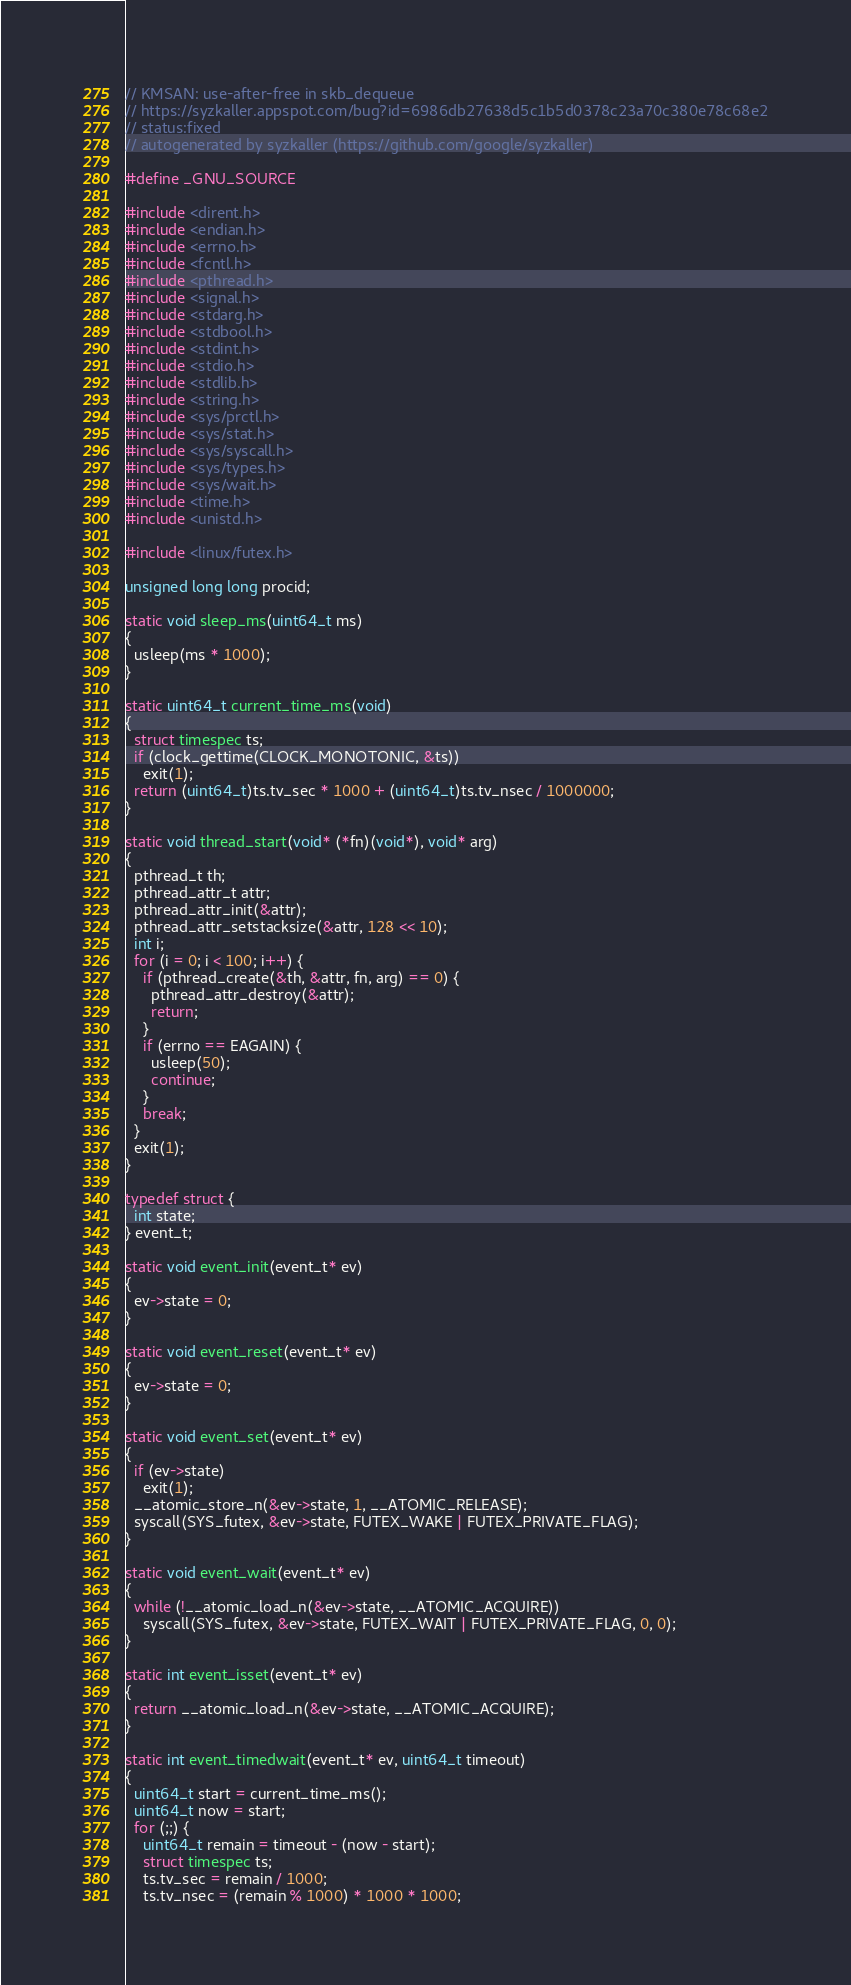Convert code to text. <code><loc_0><loc_0><loc_500><loc_500><_C_>// KMSAN: use-after-free in skb_dequeue
// https://syzkaller.appspot.com/bug?id=6986db27638d5c1b5d0378c23a70c380e78c68e2
// status:fixed
// autogenerated by syzkaller (https://github.com/google/syzkaller)

#define _GNU_SOURCE

#include <dirent.h>
#include <endian.h>
#include <errno.h>
#include <fcntl.h>
#include <pthread.h>
#include <signal.h>
#include <stdarg.h>
#include <stdbool.h>
#include <stdint.h>
#include <stdio.h>
#include <stdlib.h>
#include <string.h>
#include <sys/prctl.h>
#include <sys/stat.h>
#include <sys/syscall.h>
#include <sys/types.h>
#include <sys/wait.h>
#include <time.h>
#include <unistd.h>

#include <linux/futex.h>

unsigned long long procid;

static void sleep_ms(uint64_t ms)
{
  usleep(ms * 1000);
}

static uint64_t current_time_ms(void)
{
  struct timespec ts;
  if (clock_gettime(CLOCK_MONOTONIC, &ts))
    exit(1);
  return (uint64_t)ts.tv_sec * 1000 + (uint64_t)ts.tv_nsec / 1000000;
}

static void thread_start(void* (*fn)(void*), void* arg)
{
  pthread_t th;
  pthread_attr_t attr;
  pthread_attr_init(&attr);
  pthread_attr_setstacksize(&attr, 128 << 10);
  int i;
  for (i = 0; i < 100; i++) {
    if (pthread_create(&th, &attr, fn, arg) == 0) {
      pthread_attr_destroy(&attr);
      return;
    }
    if (errno == EAGAIN) {
      usleep(50);
      continue;
    }
    break;
  }
  exit(1);
}

typedef struct {
  int state;
} event_t;

static void event_init(event_t* ev)
{
  ev->state = 0;
}

static void event_reset(event_t* ev)
{
  ev->state = 0;
}

static void event_set(event_t* ev)
{
  if (ev->state)
    exit(1);
  __atomic_store_n(&ev->state, 1, __ATOMIC_RELEASE);
  syscall(SYS_futex, &ev->state, FUTEX_WAKE | FUTEX_PRIVATE_FLAG);
}

static void event_wait(event_t* ev)
{
  while (!__atomic_load_n(&ev->state, __ATOMIC_ACQUIRE))
    syscall(SYS_futex, &ev->state, FUTEX_WAIT | FUTEX_PRIVATE_FLAG, 0, 0);
}

static int event_isset(event_t* ev)
{
  return __atomic_load_n(&ev->state, __ATOMIC_ACQUIRE);
}

static int event_timedwait(event_t* ev, uint64_t timeout)
{
  uint64_t start = current_time_ms();
  uint64_t now = start;
  for (;;) {
    uint64_t remain = timeout - (now - start);
    struct timespec ts;
    ts.tv_sec = remain / 1000;
    ts.tv_nsec = (remain % 1000) * 1000 * 1000;</code> 